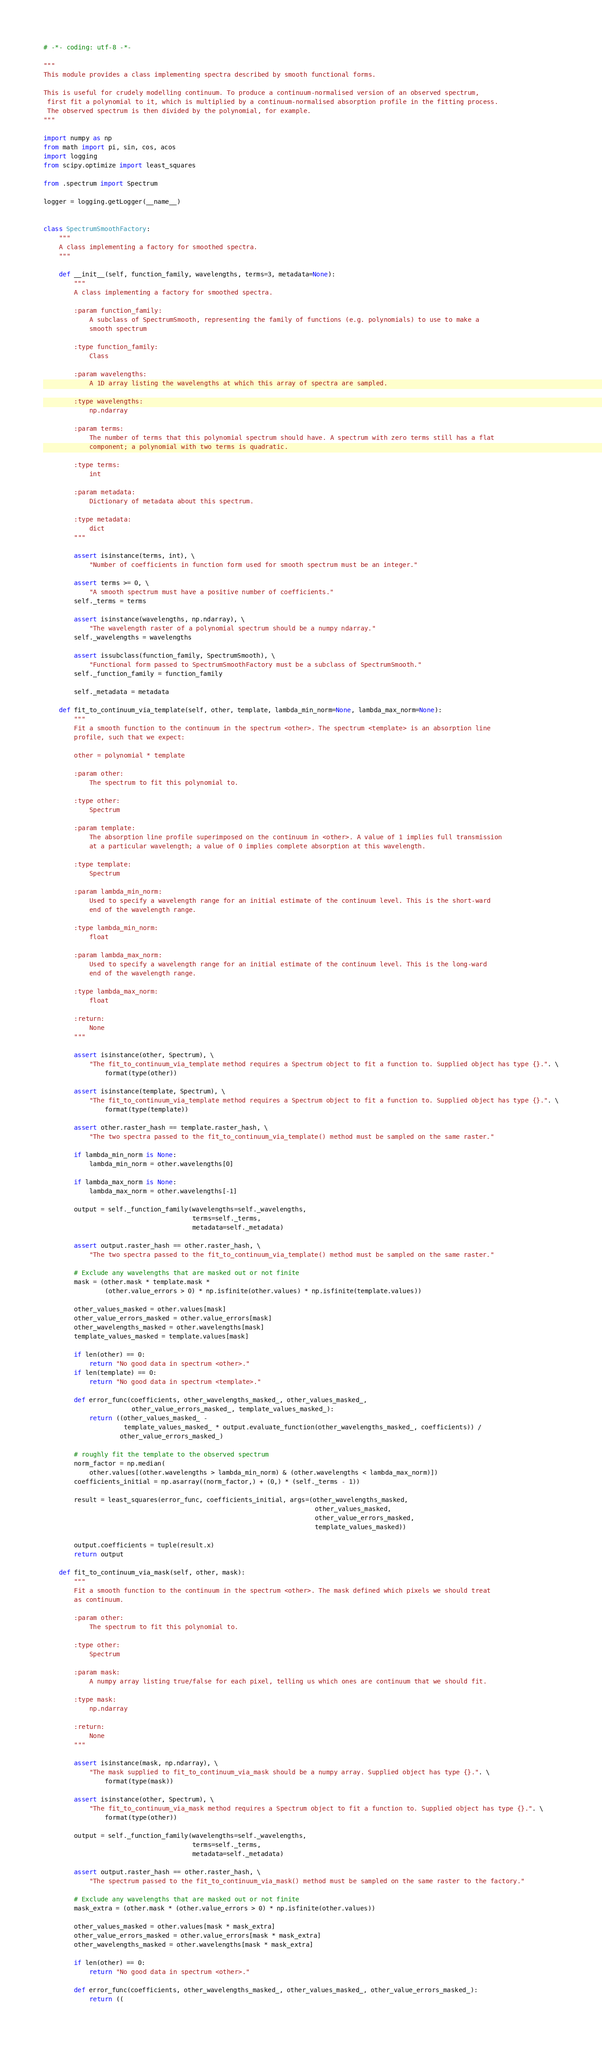Convert code to text. <code><loc_0><loc_0><loc_500><loc_500><_Python_># -*- coding: utf-8 -*-

"""
This module provides a class implementing spectra described by smooth functional forms.

This is useful for crudely modelling continuum. To produce a continuum-normalised version of an observed spectrum,
 first fit a polynomial to it, which is multiplied by a continuum-normalised absorption profile in the fitting process.
 The observed spectrum is then divided by the polynomial, for example.
"""

import numpy as np
from math import pi, sin, cos, acos
import logging
from scipy.optimize import least_squares

from .spectrum import Spectrum

logger = logging.getLogger(__name__)


class SpectrumSmoothFactory:
    """
    A class implementing a factory for smoothed spectra.
    """

    def __init__(self, function_family, wavelengths, terms=3, metadata=None):
        """
        A class implementing a factory for smoothed spectra.

        :param function_family:
            A subclass of SpectrumSmooth, representing the family of functions (e.g. polynomials) to use to make a
            smooth spectrum

        :type function_family:
            Class
        
        :param wavelengths: 
            A 1D array listing the wavelengths at which this array of spectra are sampled.
            
        :type wavelengths:
            np.ndarray
            
        :param terms:
            The number of terms that this polynomial spectrum should have. A spectrum with zero terms still has a flat
            component; a polynomial with two terms is quadratic.
            
        :type terms:
            int
            
        :param metadata: 
            Dictionary of metadata about this spectrum.
            
        :type metadata:
            dict
        """

        assert isinstance(terms, int), \
            "Number of coefficients in function form used for smooth spectrum must be an integer."

        assert terms >= 0, \
            "A smooth spectrum must have a positive number of coefficients."
        self._terms = terms

        assert isinstance(wavelengths, np.ndarray), \
            "The wavelength raster of a polynomial spectrum should be a numpy ndarray."
        self._wavelengths = wavelengths

        assert issubclass(function_family, SpectrumSmooth), \
            "Functional form passed to SpectrumSmoothFactory must be a subclass of SpectrumSmooth."
        self._function_family = function_family

        self._metadata = metadata

    def fit_to_continuum_via_template(self, other, template, lambda_min_norm=None, lambda_max_norm=None):
        """
        Fit a smooth function to the continuum in the spectrum <other>. The spectrum <template> is an absorption line
        profile, such that we expect:
        
        other = polynomial * template
        
        :param other:
            The spectrum to fit this polynomial to.
            
        :type other:
            Spectrum
        
        :param template:
            The absorption line profile superimposed on the continuum in <other>. A value of 1 implies full transmission
            at a particular wavelength; a value of 0 implies complete absorption at this wavelength.
            
        :type template:
            Spectrum
            
        :param lambda_min_norm:
            Used to specify a wavelength range for an initial estimate of the continuum level. This is the short-ward
            end of the wavelength range.
            
        :type lambda_min_norm:
            float
            
        :param lambda_max_norm:
            Used to specify a wavelength range for an initial estimate of the continuum level. This is the long-ward
            end of the wavelength range.
            
        :type lambda_max_norm:
            float
            
        :return:
            None
        """

        assert isinstance(other, Spectrum), \
            "The fit_to_continuum_via_template method requires a Spectrum object to fit a function to. Supplied object has type {}.". \
                format(type(other))

        assert isinstance(template, Spectrum), \
            "The fit_to_continuum_via_template method requires a Spectrum object to fit a function to. Supplied object has type {}.". \
                format(type(template))

        assert other.raster_hash == template.raster_hash, \
            "The two spectra passed to the fit_to_continuum_via_template() method must be sampled on the same raster."

        if lambda_min_norm is None:
            lambda_min_norm = other.wavelengths[0]

        if lambda_max_norm is None:
            lambda_max_norm = other.wavelengths[-1]

        output = self._function_family(wavelengths=self._wavelengths,
                                       terms=self._terms,
                                       metadata=self._metadata)

        assert output.raster_hash == other.raster_hash, \
            "The two spectra passed to the fit_to_continuum_via_template() method must be sampled on the same raster."

        # Exclude any wavelengths that are masked out or not finite
        mask = (other.mask * template.mask *
                (other.value_errors > 0) * np.isfinite(other.values) * np.isfinite(template.values))

        other_values_masked = other.values[mask]
        other_value_errors_masked = other.value_errors[mask]
        other_wavelengths_masked = other.wavelengths[mask]
        template_values_masked = template.values[mask]

        if len(other) == 0:
            return "No good data in spectrum <other>."
        if len(template) == 0:
            return "No good data in spectrum <template>."

        def error_func(coefficients, other_wavelengths_masked_, other_values_masked_,
                       other_value_errors_masked_, template_values_masked_):
            return ((other_values_masked_ -
                     template_values_masked_ * output.evaluate_function(other_wavelengths_masked_, coefficients)) /
                    other_value_errors_masked_)

        # roughly fit the template to the observed spectrum
        norm_factor = np.median(
            other.values[(other.wavelengths > lambda_min_norm) & (other.wavelengths < lambda_max_norm)])
        coefficients_initial = np.asarray((norm_factor,) + (0,) * (self._terms - 1))

        result = least_squares(error_func, coefficients_initial, args=(other_wavelengths_masked,
                                                                       other_values_masked,
                                                                       other_value_errors_masked,
                                                                       template_values_masked))

        output.coefficients = tuple(result.x)
        return output

    def fit_to_continuum_via_mask(self, other, mask):
        """
        Fit a smooth function to the continuum in the spectrum <other>. The mask defined which pixels we should treat
        as continuum.

        :param other:
            The spectrum to fit this polynomial to.

        :type other:
            Spectrum

        :param mask:
            A numpy array listing true/false for each pixel, telling us which ones are continuum that we should fit.

        :type mask:
            np.ndarray

        :return:
            None
        """

        assert isinstance(mask, np.ndarray), \
            "The mask supplied to fit_to_continuum_via_mask should be a numpy array. Supplied object has type {}.". \
                format(type(mask))

        assert isinstance(other, Spectrum), \
            "The fit_to_continuum_via_mask method requires a Spectrum object to fit a function to. Supplied object has type {}.". \
                format(type(other))

        output = self._function_family(wavelengths=self._wavelengths,
                                       terms=self._terms,
                                       metadata=self._metadata)

        assert output.raster_hash == other.raster_hash, \
            "The spectrum passed to the fit_to_continuum_via_mask() method must be sampled on the same raster to the factory."

        # Exclude any wavelengths that are masked out or not finite
        mask_extra = (other.mask * (other.value_errors > 0) * np.isfinite(other.values))

        other_values_masked = other.values[mask * mask_extra]
        other_value_errors_masked = other.value_errors[mask * mask_extra]
        other_wavelengths_masked = other.wavelengths[mask * mask_extra]

        if len(other) == 0:
            return "No good data in spectrum <other>."

        def error_func(coefficients, other_wavelengths_masked_, other_values_masked_, other_value_errors_masked_):
            return ((</code> 